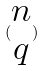<formula> <loc_0><loc_0><loc_500><loc_500>( \begin{matrix} n \\ q \end{matrix} )</formula> 